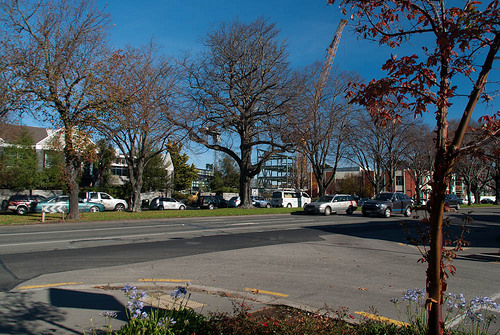<image>
Can you confirm if the sky is behind the building? Yes. From this viewpoint, the sky is positioned behind the building, with the building partially or fully occluding the sky. Where is the tree in relation to the car? Is it next to the car? No. The tree is not positioned next to the car. They are located in different areas of the scene. 